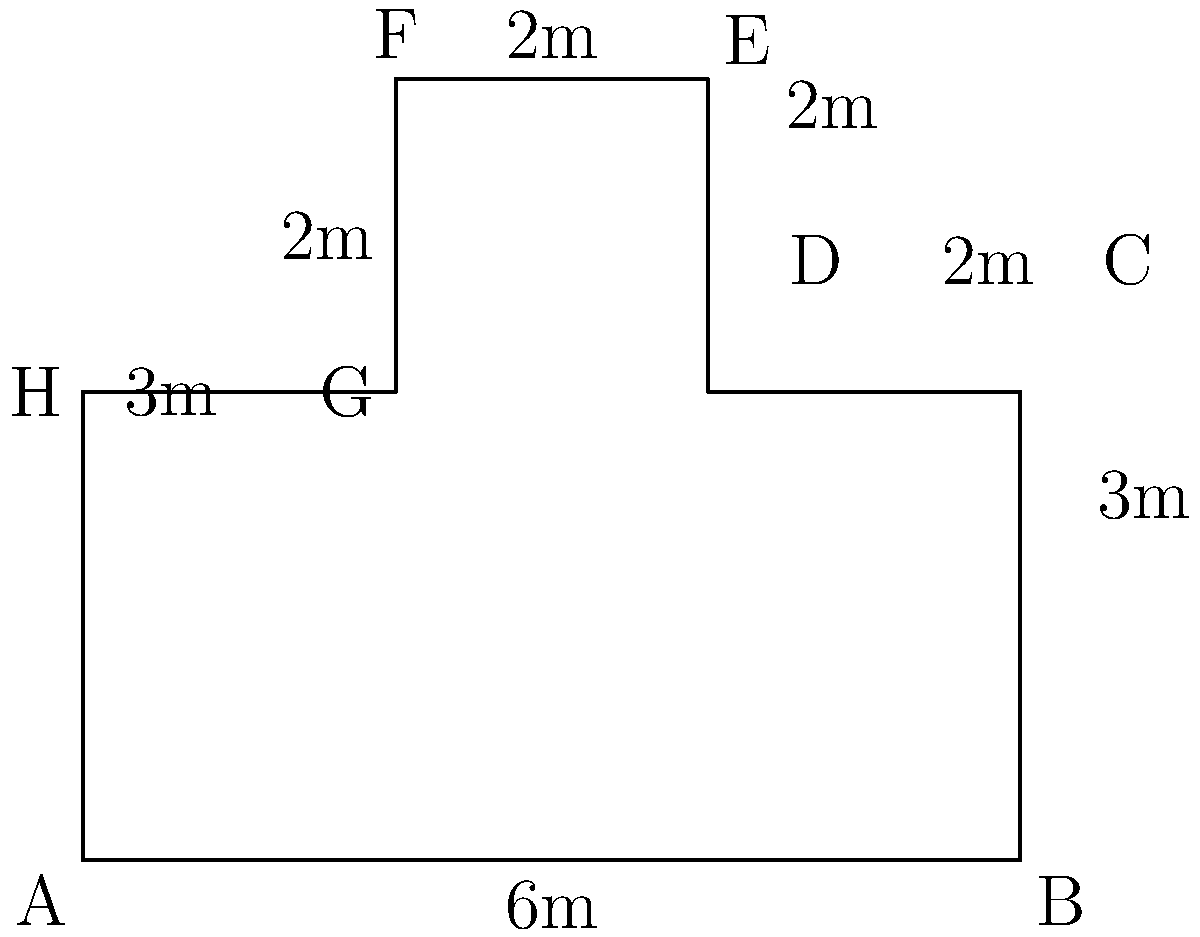A trendy new bar in your college town has an irregularly shaped bar counter. The bar manager asks you to calculate the area of the counter to determine how many patrons it can accommodate. Given the dimensions in meters as shown in the diagram, what is the total area of the bar counter in square meters? To find the area of this irregular polygon, we can divide it into rectangles and calculate their areas separately:

1. Rectangle ABCH: $6m \times 3m = 18m^2$
2. Rectangle CDEF: $2m \times 5m = 10m^2$

Total area = Area of ABCH + Area of CDEF
$$ \text{Total Area} = 18m^2 + 10m^2 = 28m^2 $$

Therefore, the total area of the bar counter is 28 square meters.
Answer: $28m^2$ 